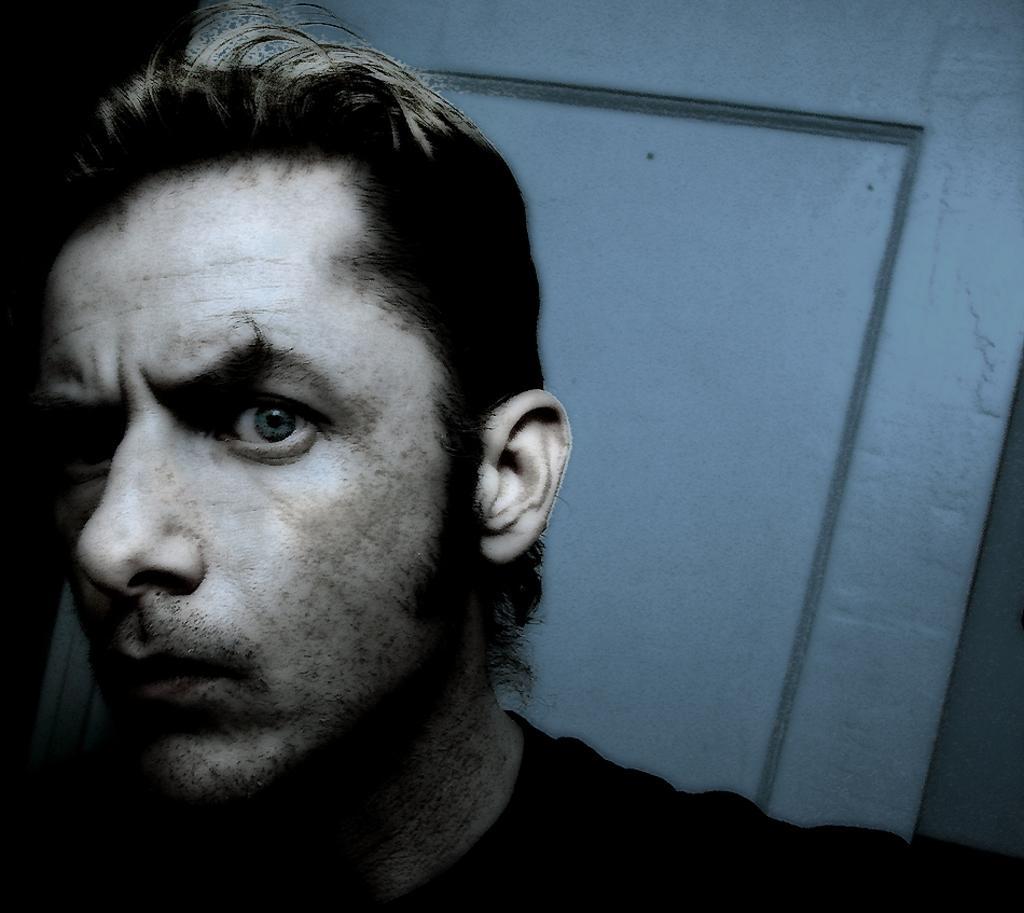Describe this image in one or two sentences. In this image in the front there is a person. In the background there is a door. 